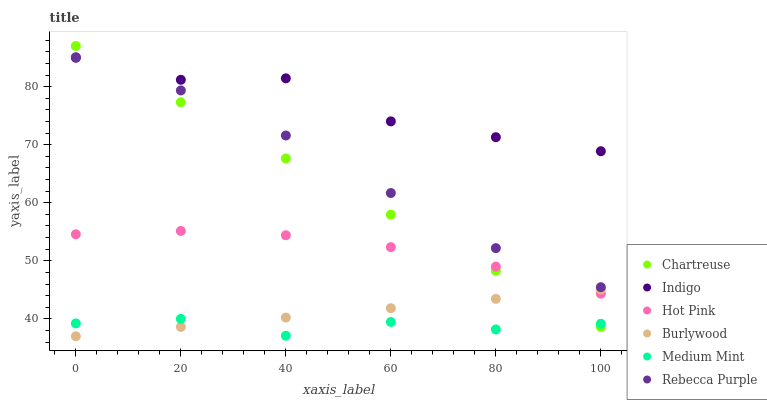Does Medium Mint have the minimum area under the curve?
Answer yes or no. Yes. Does Indigo have the maximum area under the curve?
Answer yes or no. Yes. Does Burlywood have the minimum area under the curve?
Answer yes or no. No. Does Burlywood have the maximum area under the curve?
Answer yes or no. No. Is Burlywood the smoothest?
Answer yes or no. Yes. Is Indigo the roughest?
Answer yes or no. Yes. Is Indigo the smoothest?
Answer yes or no. No. Is Burlywood the roughest?
Answer yes or no. No. Does Burlywood have the lowest value?
Answer yes or no. Yes. Does Indigo have the lowest value?
Answer yes or no. No. Does Chartreuse have the highest value?
Answer yes or no. Yes. Does Indigo have the highest value?
Answer yes or no. No. Is Burlywood less than Rebecca Purple?
Answer yes or no. Yes. Is Rebecca Purple greater than Medium Mint?
Answer yes or no. Yes. Does Indigo intersect Rebecca Purple?
Answer yes or no. Yes. Is Indigo less than Rebecca Purple?
Answer yes or no. No. Is Indigo greater than Rebecca Purple?
Answer yes or no. No. Does Burlywood intersect Rebecca Purple?
Answer yes or no. No. 